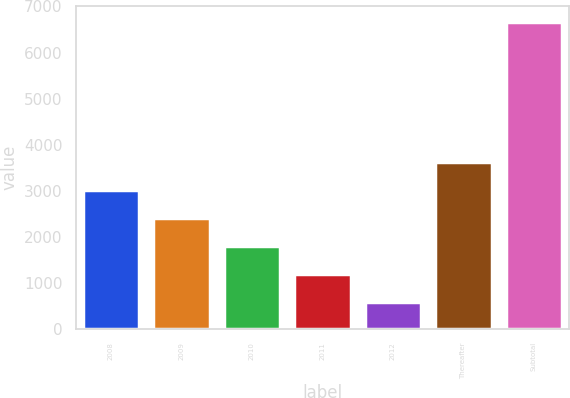Convert chart to OTSL. <chart><loc_0><loc_0><loc_500><loc_500><bar_chart><fcel>2008<fcel>2009<fcel>2010<fcel>2011<fcel>2012<fcel>Thereafter<fcel>Subtotal<nl><fcel>3022.4<fcel>2414.8<fcel>1807.2<fcel>1199.6<fcel>592<fcel>3630<fcel>6668<nl></chart> 